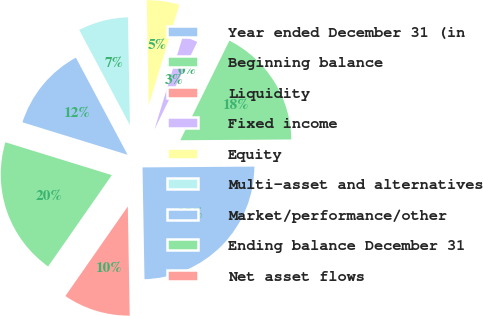Convert chart. <chart><loc_0><loc_0><loc_500><loc_500><pie_chart><fcel>Year ended December 31 (in<fcel>Beginning balance<fcel>Liquidity<fcel>Fixed income<fcel>Equity<fcel>Multi-asset and alternatives<fcel>Market/performance/other<fcel>Ending balance December 31<fcel>Net asset flows<nl><fcel>24.84%<fcel>17.6%<fcel>0.05%<fcel>2.53%<fcel>5.01%<fcel>7.49%<fcel>12.45%<fcel>20.08%<fcel>9.97%<nl></chart> 